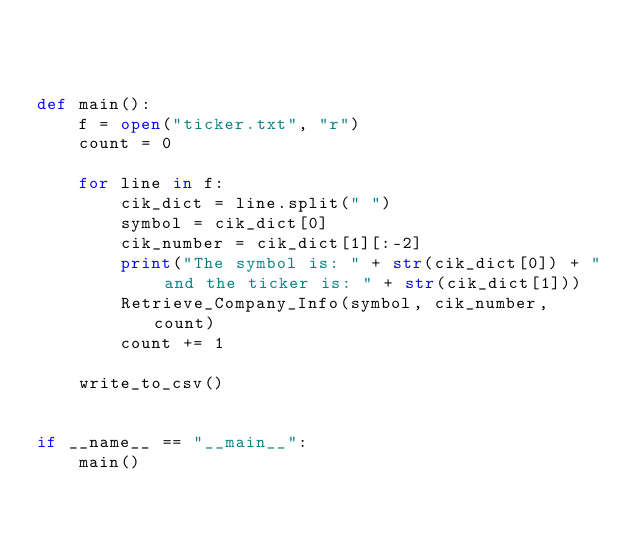<code> <loc_0><loc_0><loc_500><loc_500><_Python_>


def main():
    f = open("ticker.txt", "r")
    count = 0

    for line in f:
        cik_dict = line.split("	")
        symbol = cik_dict[0]
        cik_number = cik_dict[1][:-2]
        print("The symbol is: " + str(cik_dict[0]) + " and the ticker is: " + str(cik_dict[1]))
        Retrieve_Company_Info(symbol, cik_number, count)
        count += 1

    write_to_csv()


if __name__ == "__main__":
    main()
</code> 